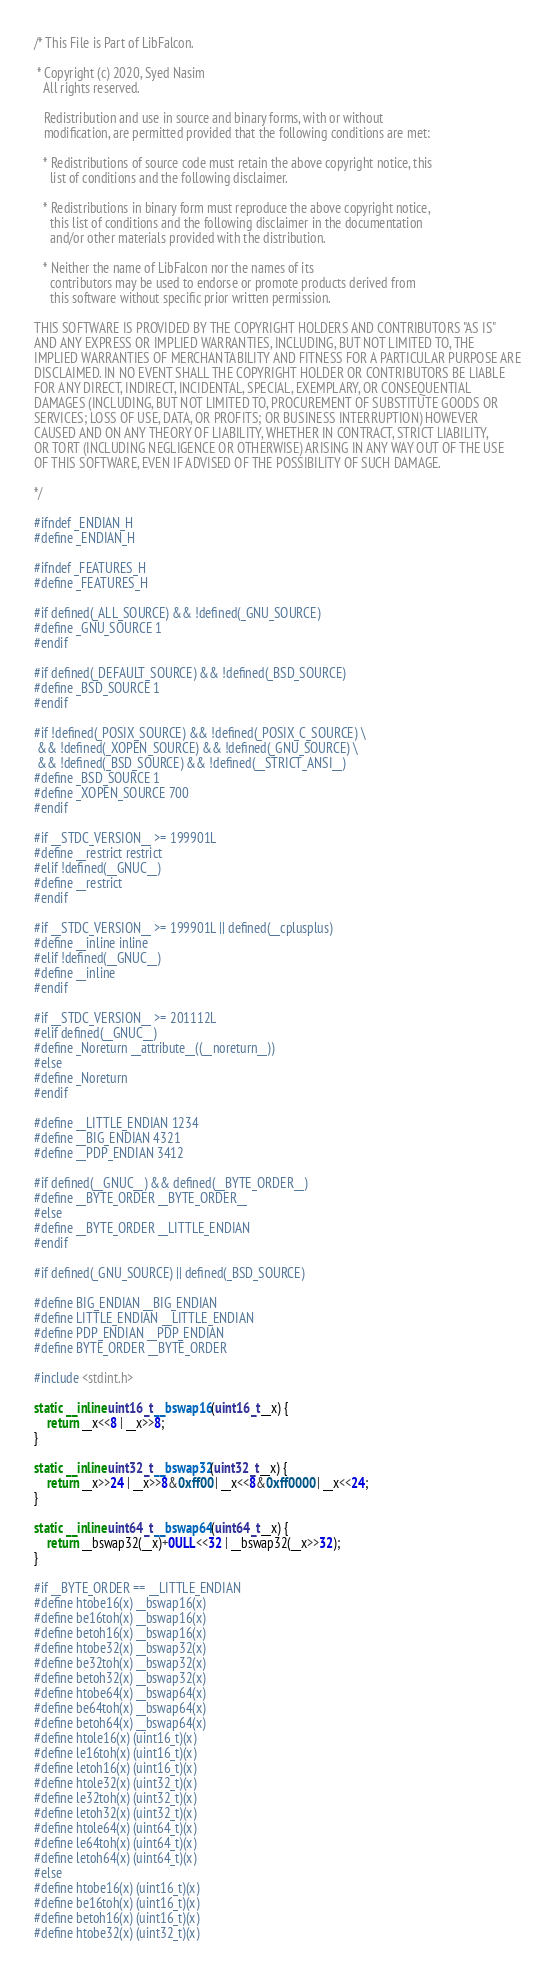<code> <loc_0><loc_0><loc_500><loc_500><_C_>/* This File is Part of LibFalcon.

 * Copyright (c) 2020, Syed Nasim
   All rights reserved.

   Redistribution and use in source and binary forms, with or without
   modification, are permitted provided that the following conditions are met:

   * Redistributions of source code must retain the above copyright notice, this
     list of conditions and the following disclaimer.

   * Redistributions in binary form must reproduce the above copyright notice,
     this list of conditions and the following disclaimer in the documentation
     and/or other materials provided with the distribution.

   * Neither the name of LibFalcon nor the names of its
     contributors may be used to endorse or promote products derived from
     this software without specific prior written permission.

THIS SOFTWARE IS PROVIDED BY THE COPYRIGHT HOLDERS AND CONTRIBUTORS "AS IS"
AND ANY EXPRESS OR IMPLIED WARRANTIES, INCLUDING, BUT NOT LIMITED TO, THE
IMPLIED WARRANTIES OF MERCHANTABILITY AND FITNESS FOR A PARTICULAR PURPOSE ARE
DISCLAIMED. IN NO EVENT SHALL THE COPYRIGHT HOLDER OR CONTRIBUTORS BE LIABLE
FOR ANY DIRECT, INDIRECT, INCIDENTAL, SPECIAL, EXEMPLARY, OR CONSEQUENTIAL
DAMAGES (INCLUDING, BUT NOT LIMITED TO, PROCUREMENT OF SUBSTITUTE GOODS OR
SERVICES; LOSS OF USE, DATA, OR PROFITS; OR BUSINESS INTERRUPTION) HOWEVER
CAUSED AND ON ANY THEORY OF LIABILITY, WHETHER IN CONTRACT, STRICT LIABILITY,
OR TORT (INCLUDING NEGLIGENCE OR OTHERWISE) ARISING IN ANY WAY OUT OF THE USE
OF THIS SOFTWARE, EVEN IF ADVISED OF THE POSSIBILITY OF SUCH DAMAGE.

*/

#ifndef _ENDIAN_H
#define _ENDIAN_H

#ifndef _FEATURES_H
#define _FEATURES_H

#if defined(_ALL_SOURCE) && !defined(_GNU_SOURCE)
#define _GNU_SOURCE 1
#endif

#if defined(_DEFAULT_SOURCE) && !defined(_BSD_SOURCE)
#define _BSD_SOURCE 1
#endif

#if !defined(_POSIX_SOURCE) && !defined(_POSIX_C_SOURCE) \
 && !defined(_XOPEN_SOURCE) && !defined(_GNU_SOURCE) \
 && !defined(_BSD_SOURCE) && !defined(__STRICT_ANSI__)
#define _BSD_SOURCE 1
#define _XOPEN_SOURCE 700
#endif

#if __STDC_VERSION__ >= 199901L
#define __restrict restrict
#elif !defined(__GNUC__)
#define __restrict
#endif

#if __STDC_VERSION__ >= 199901L || defined(__cplusplus)
#define __inline inline
#elif !defined(__GNUC__)
#define __inline
#endif

#if __STDC_VERSION__ >= 201112L
#elif defined(__GNUC__)
#define _Noreturn __attribute__((__noreturn__))
#else
#define _Noreturn
#endif

#define __LITTLE_ENDIAN 1234
#define __BIG_ENDIAN 4321
#define __PDP_ENDIAN 3412

#if defined(__GNUC__) && defined(__BYTE_ORDER__)
#define __BYTE_ORDER __BYTE_ORDER__
#else
#define __BYTE_ORDER __LITTLE_ENDIAN
#endif

#if defined(_GNU_SOURCE) || defined(_BSD_SOURCE)

#define BIG_ENDIAN __BIG_ENDIAN
#define LITTLE_ENDIAN __LITTLE_ENDIAN
#define PDP_ENDIAN __PDP_ENDIAN
#define BYTE_ORDER __BYTE_ORDER

#include <stdint.h>

static __inline uint16_t __bswap16(uint16_t __x) {
    return __x<<8 | __x>>8;
}

static __inline uint32_t __bswap32(uint32_t __x) {
    return __x>>24 | __x>>8&0xff00 | __x<<8&0xff0000 | __x<<24;
}

static __inline uint64_t __bswap64(uint64_t __x) {
    return __bswap32(__x)+0ULL<<32 | __bswap32(__x>>32);
}

#if __BYTE_ORDER == __LITTLE_ENDIAN
#define htobe16(x) __bswap16(x)
#define be16toh(x) __bswap16(x)
#define betoh16(x) __bswap16(x)
#define htobe32(x) __bswap32(x)
#define be32toh(x) __bswap32(x)
#define betoh32(x) __bswap32(x)
#define htobe64(x) __bswap64(x)
#define be64toh(x) __bswap64(x)
#define betoh64(x) __bswap64(x)
#define htole16(x) (uint16_t)(x)
#define le16toh(x) (uint16_t)(x)
#define letoh16(x) (uint16_t)(x)
#define htole32(x) (uint32_t)(x)
#define le32toh(x) (uint32_t)(x)
#define letoh32(x) (uint32_t)(x)
#define htole64(x) (uint64_t)(x)
#define le64toh(x) (uint64_t)(x)
#define letoh64(x) (uint64_t)(x)
#else
#define htobe16(x) (uint16_t)(x)
#define be16toh(x) (uint16_t)(x)
#define betoh16(x) (uint16_t)(x)
#define htobe32(x) (uint32_t)(x)</code> 